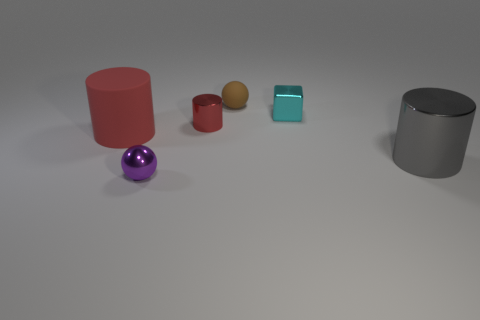Add 3 large rubber things. How many objects exist? 9 Subtract all spheres. How many objects are left? 4 Subtract all green metallic cylinders. Subtract all metal things. How many objects are left? 2 Add 4 gray cylinders. How many gray cylinders are left? 5 Add 5 cyan matte balls. How many cyan matte balls exist? 5 Subtract 0 yellow spheres. How many objects are left? 6 